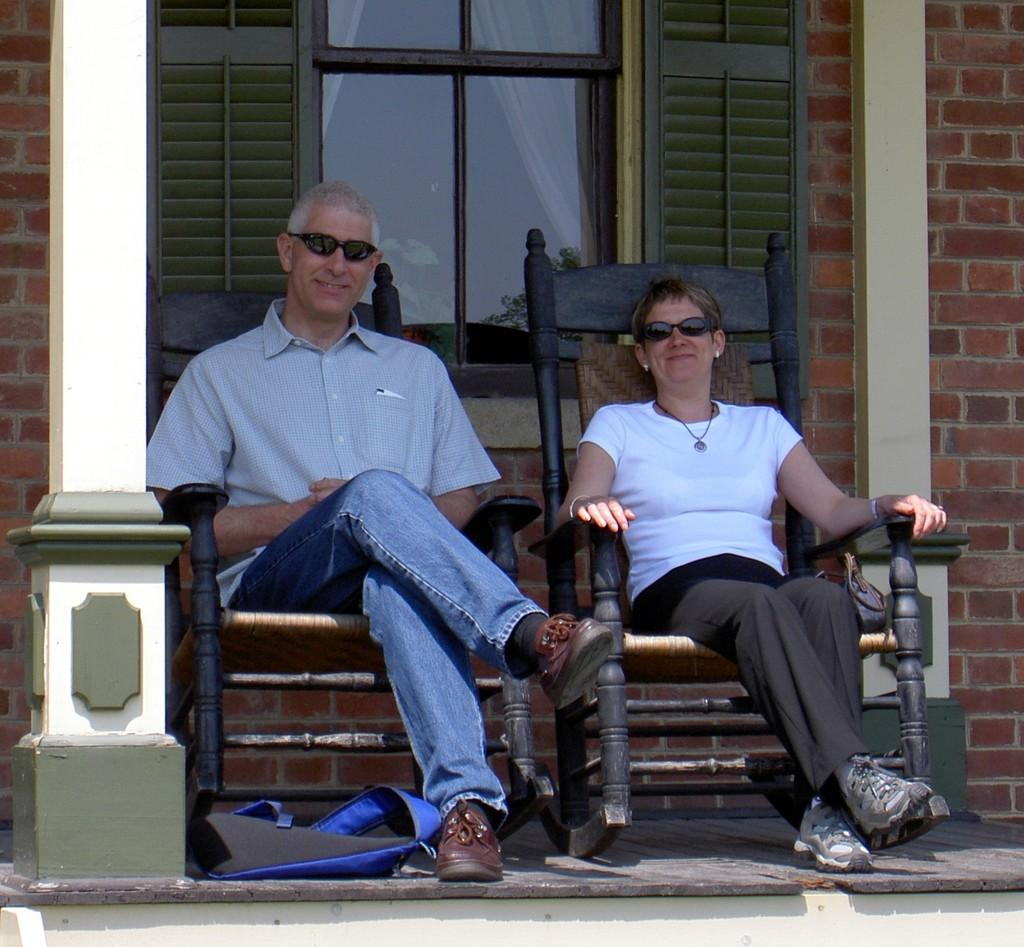How many people are sitting in the image? There are two people sitting on chairs in the image. What is on the floor near the people? There is a bag on the floor in the image. What can be seen in the distance behind the people? There is a building visible in the background of the image. Is there any indication of an indoor or outdoor setting in the image? The presence of a window in the background suggests that the image is taken indoors. What type of nerve is visible in the image? There is no nerve visible in the image; it features two people sitting on chairs, a bag on the floor, and a building and window in the background. 